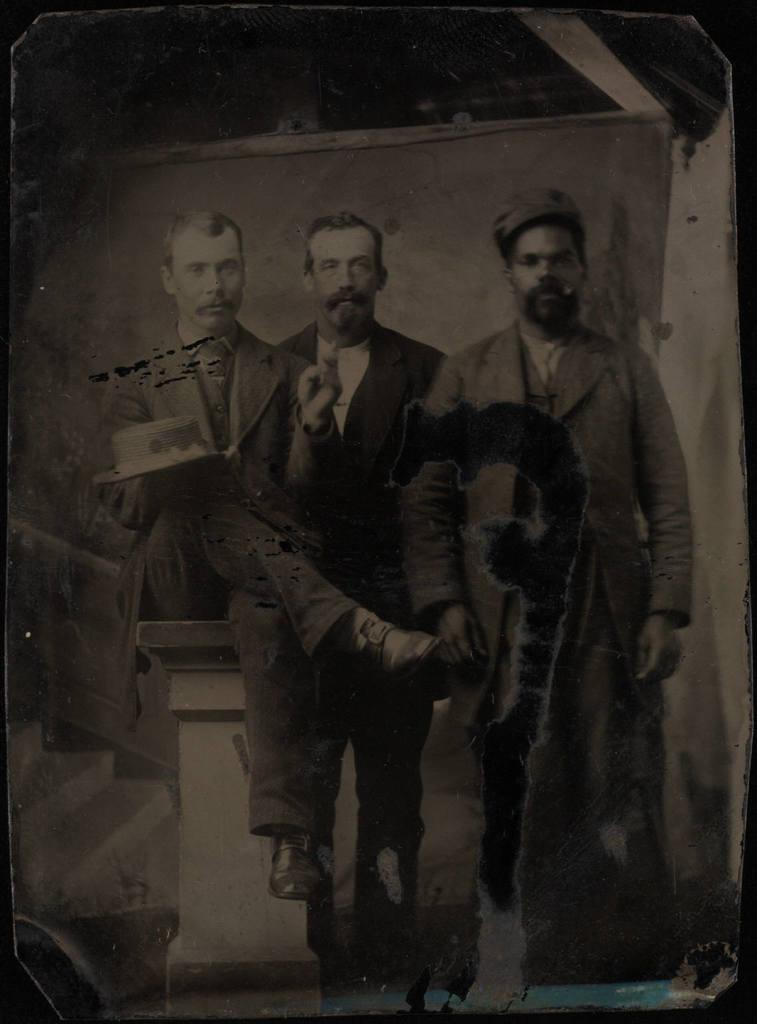What is the color scheme of the image? The image is in black and white. How many people are in the image? There are three men in the image. What is the position of one of the men? One of the men is sitting. What type of clothing are the men wearing? All three men are wearing suits. How many kittens are playing with the yoke in the image? There are no kittens or yokes present in the image. What type of picture is hanging on the wall in the image? The image provided does not contain any information about a picture hanging on the wall. 